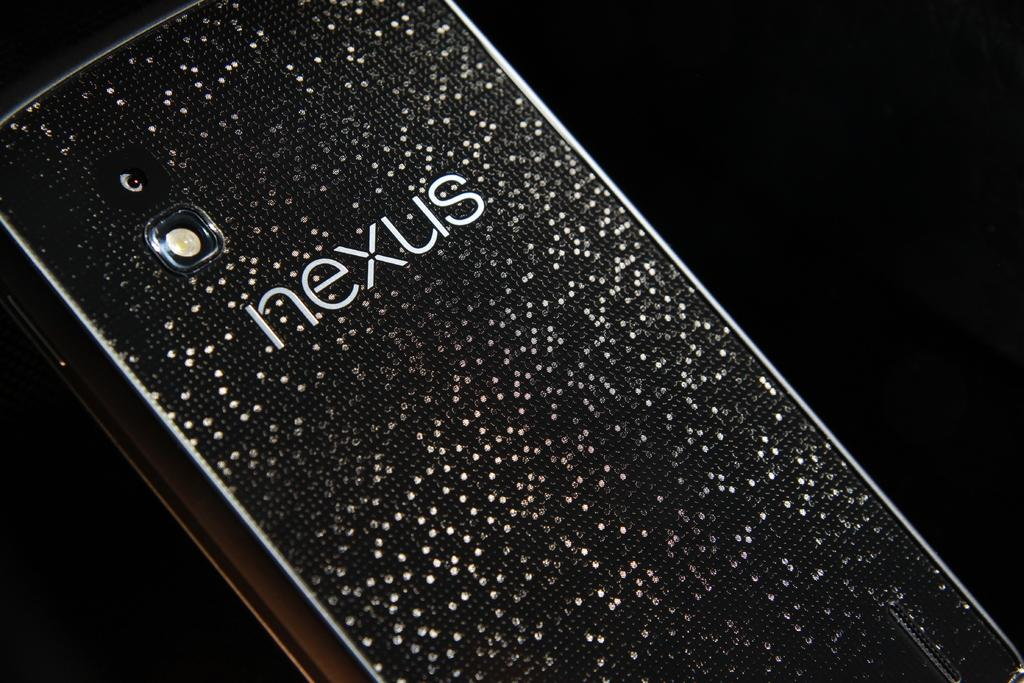<image>
Render a clear and concise summary of the photo. the word Nexus that is on a phone 